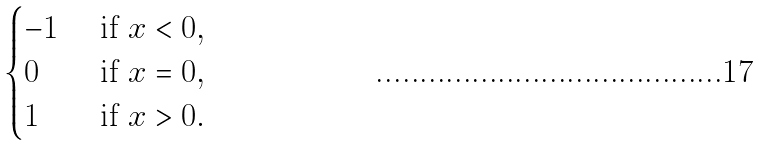Convert formula to latex. <formula><loc_0><loc_0><loc_500><loc_500>\begin{cases} - 1 & \text { if } x < 0 , \\ 0 & \text { if } x = 0 , \\ 1 & \text { if } x > 0 . \end{cases}</formula> 